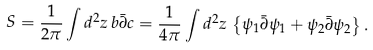<formula> <loc_0><loc_0><loc_500><loc_500>S = \frac { 1 } { 2 \pi } \int d ^ { 2 } z \, b \bar { \partial } c = \frac { 1 } { 4 \pi } \int d ^ { 2 } z \, \left \{ \psi _ { 1 } \bar { \partial } \psi _ { 1 } + \psi _ { 2 } \bar { \partial } \psi _ { 2 } \right \} .</formula> 